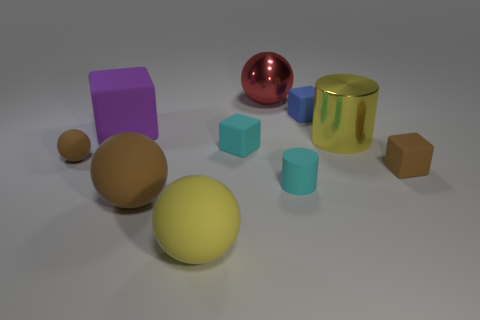Subtract all blocks. How many objects are left? 6 Add 9 large red spheres. How many large red spheres are left? 10 Add 1 small things. How many small things exist? 6 Subtract 1 brown blocks. How many objects are left? 9 Subtract all green metallic blocks. Subtract all tiny balls. How many objects are left? 9 